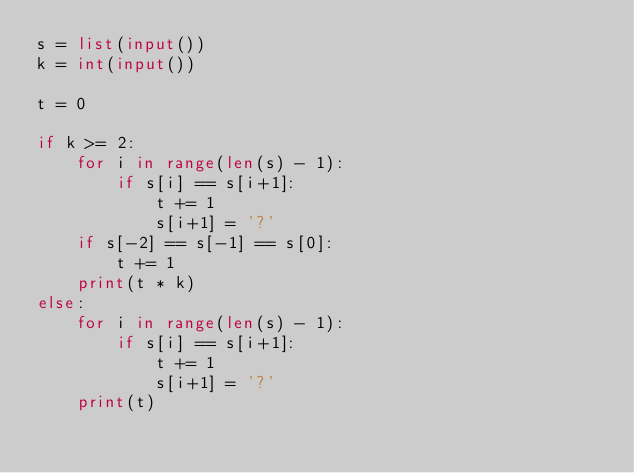<code> <loc_0><loc_0><loc_500><loc_500><_Python_>s = list(input())
k = int(input())

t = 0

if k >= 2:
    for i in range(len(s) - 1):
        if s[i] == s[i+1]:
            t += 1
            s[i+1] = '?'
    if s[-2] == s[-1] == s[0]:
        t += 1
    print(t * k)
else:
    for i in range(len(s) - 1):
        if s[i] == s[i+1]:
            t += 1
            s[i+1] = '?'
    print(t)</code> 